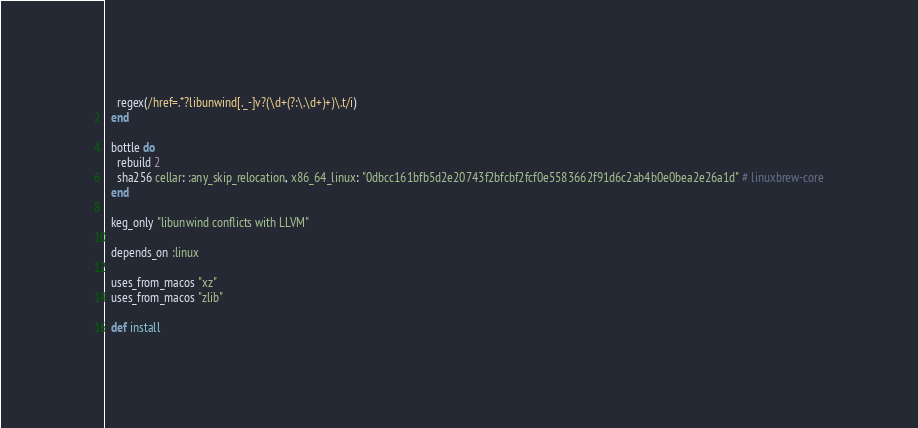<code> <loc_0><loc_0><loc_500><loc_500><_Ruby_>    regex(/href=.*?libunwind[._-]v?(\d+(?:\.\d+)+)\.t/i)
  end

  bottle do
    rebuild 2
    sha256 cellar: :any_skip_relocation, x86_64_linux: "0dbcc161bfb5d2e20743f2bfcbf2fcf0e5583662f91d6c2ab4b0e0bea2e26a1d" # linuxbrew-core
  end

  keg_only "libunwind conflicts with LLVM"

  depends_on :linux

  uses_from_macos "xz"
  uses_from_macos "zlib"

  def install</code> 